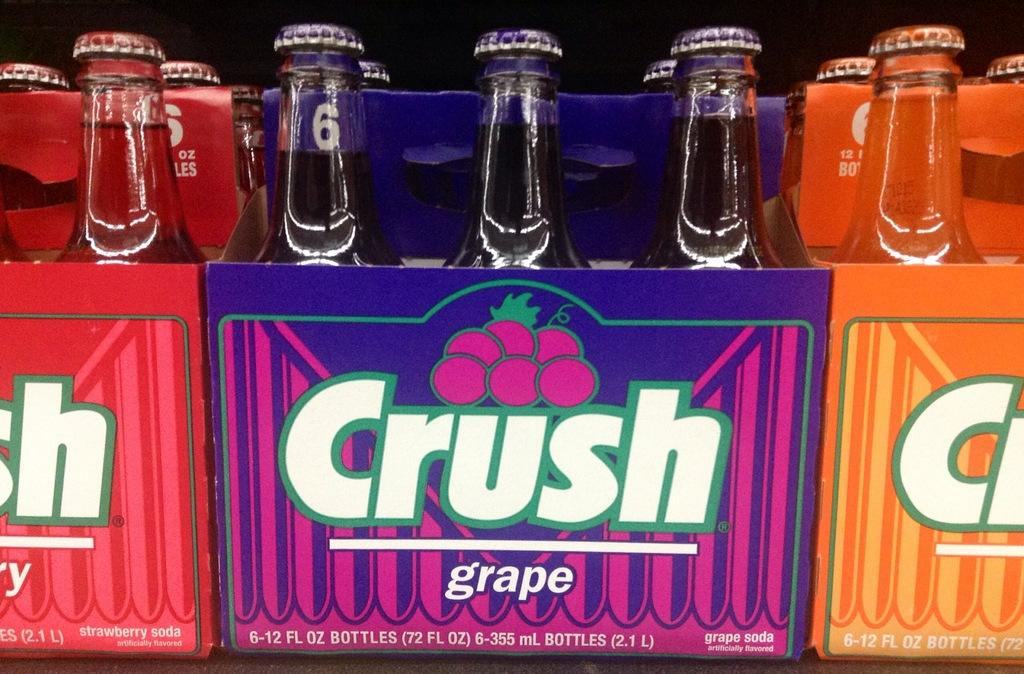<image>
Present a compact description of the photo's key features. A purple box of grape Crush sits between a red and orange box of the same. 